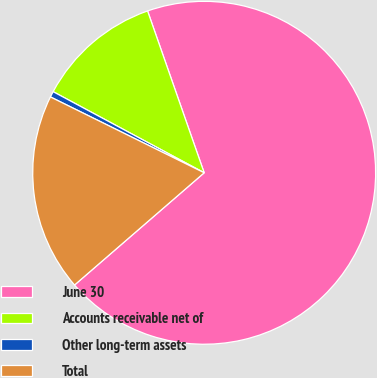Convert chart. <chart><loc_0><loc_0><loc_500><loc_500><pie_chart><fcel>June 30<fcel>Accounts receivable net of<fcel>Other long-term assets<fcel>Total<nl><fcel>69.0%<fcel>11.8%<fcel>0.55%<fcel>18.65%<nl></chart> 